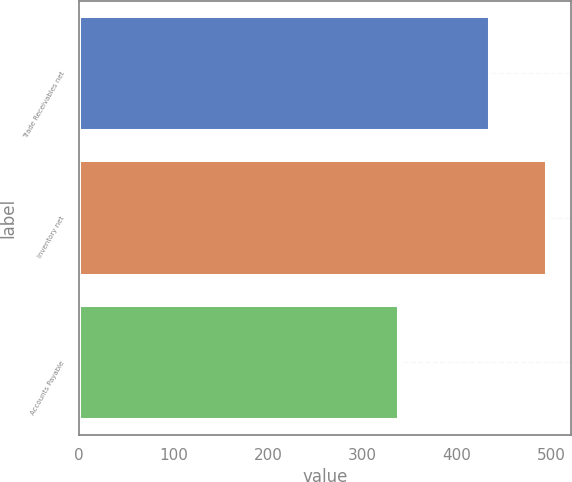<chart> <loc_0><loc_0><loc_500><loc_500><bar_chart><fcel>Trade Receivables net<fcel>Inventory net<fcel>Accounts Payable<nl><fcel>435<fcel>496<fcel>339<nl></chart> 